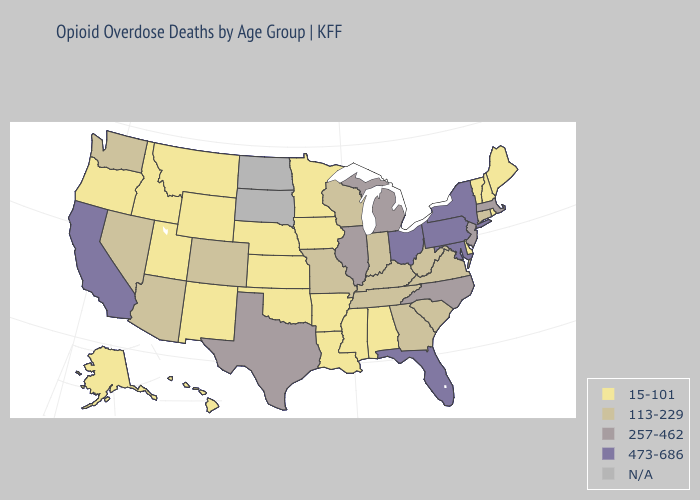Name the states that have a value in the range N/A?
Write a very short answer. North Dakota, South Dakota. Name the states that have a value in the range N/A?
Concise answer only. North Dakota, South Dakota. What is the highest value in states that border Washington?
Write a very short answer. 15-101. Name the states that have a value in the range 257-462?
Concise answer only. Illinois, Massachusetts, Michigan, New Jersey, North Carolina, Texas. Name the states that have a value in the range 257-462?
Write a very short answer. Illinois, Massachusetts, Michigan, New Jersey, North Carolina, Texas. Which states have the lowest value in the West?
Keep it brief. Alaska, Hawaii, Idaho, Montana, New Mexico, Oregon, Utah, Wyoming. Does Arkansas have the lowest value in the South?
Quick response, please. Yes. Does the map have missing data?
Give a very brief answer. Yes. Name the states that have a value in the range 15-101?
Short answer required. Alabama, Alaska, Arkansas, Delaware, Hawaii, Idaho, Iowa, Kansas, Louisiana, Maine, Minnesota, Mississippi, Montana, Nebraska, New Hampshire, New Mexico, Oklahoma, Oregon, Rhode Island, Utah, Vermont, Wyoming. Name the states that have a value in the range 473-686?
Be succinct. California, Florida, Maryland, New York, Ohio, Pennsylvania. What is the lowest value in the West?
Keep it brief. 15-101. What is the highest value in states that border Michigan?
Give a very brief answer. 473-686. Among the states that border Missouri , does Tennessee have the lowest value?
Answer briefly. No. Which states have the highest value in the USA?
Concise answer only. California, Florida, Maryland, New York, Ohio, Pennsylvania. How many symbols are there in the legend?
Answer briefly. 5. 